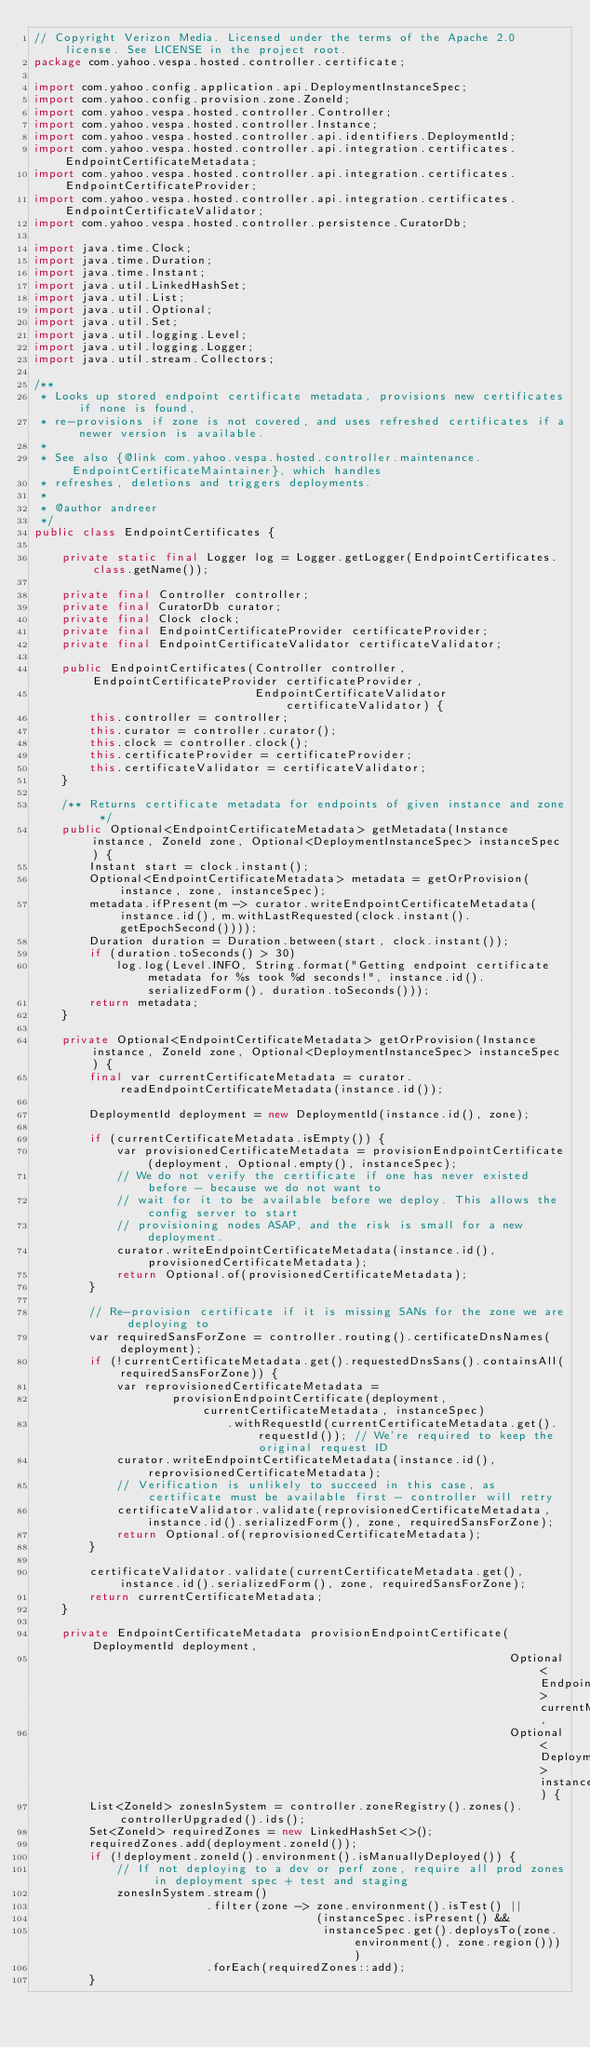Convert code to text. <code><loc_0><loc_0><loc_500><loc_500><_Java_>// Copyright Verizon Media. Licensed under the terms of the Apache 2.0 license. See LICENSE in the project root.
package com.yahoo.vespa.hosted.controller.certificate;

import com.yahoo.config.application.api.DeploymentInstanceSpec;
import com.yahoo.config.provision.zone.ZoneId;
import com.yahoo.vespa.hosted.controller.Controller;
import com.yahoo.vespa.hosted.controller.Instance;
import com.yahoo.vespa.hosted.controller.api.identifiers.DeploymentId;
import com.yahoo.vespa.hosted.controller.api.integration.certificates.EndpointCertificateMetadata;
import com.yahoo.vespa.hosted.controller.api.integration.certificates.EndpointCertificateProvider;
import com.yahoo.vespa.hosted.controller.api.integration.certificates.EndpointCertificateValidator;
import com.yahoo.vespa.hosted.controller.persistence.CuratorDb;

import java.time.Clock;
import java.time.Duration;
import java.time.Instant;
import java.util.LinkedHashSet;
import java.util.List;
import java.util.Optional;
import java.util.Set;
import java.util.logging.Level;
import java.util.logging.Logger;
import java.util.stream.Collectors;

/**
 * Looks up stored endpoint certificate metadata, provisions new certificates if none is found,
 * re-provisions if zone is not covered, and uses refreshed certificates if a newer version is available.
 *
 * See also {@link com.yahoo.vespa.hosted.controller.maintenance.EndpointCertificateMaintainer}, which handles
 * refreshes, deletions and triggers deployments.
 *
 * @author andreer
 */
public class EndpointCertificates {

    private static final Logger log = Logger.getLogger(EndpointCertificates.class.getName());

    private final Controller controller;
    private final CuratorDb curator;
    private final Clock clock;
    private final EndpointCertificateProvider certificateProvider;
    private final EndpointCertificateValidator certificateValidator;

    public EndpointCertificates(Controller controller, EndpointCertificateProvider certificateProvider,
                                EndpointCertificateValidator certificateValidator) {
        this.controller = controller;
        this.curator = controller.curator();
        this.clock = controller.clock();
        this.certificateProvider = certificateProvider;
        this.certificateValidator = certificateValidator;
    }

    /** Returns certificate metadata for endpoints of given instance and zone */
    public Optional<EndpointCertificateMetadata> getMetadata(Instance instance, ZoneId zone, Optional<DeploymentInstanceSpec> instanceSpec) {
        Instant start = clock.instant();
        Optional<EndpointCertificateMetadata> metadata = getOrProvision(instance, zone, instanceSpec);
        metadata.ifPresent(m -> curator.writeEndpointCertificateMetadata(instance.id(), m.withLastRequested(clock.instant().getEpochSecond())));
        Duration duration = Duration.between(start, clock.instant());
        if (duration.toSeconds() > 30)
            log.log(Level.INFO, String.format("Getting endpoint certificate metadata for %s took %d seconds!", instance.id().serializedForm(), duration.toSeconds()));
        return metadata;
    }

    private Optional<EndpointCertificateMetadata> getOrProvision(Instance instance, ZoneId zone, Optional<DeploymentInstanceSpec> instanceSpec) {
        final var currentCertificateMetadata = curator.readEndpointCertificateMetadata(instance.id());

        DeploymentId deployment = new DeploymentId(instance.id(), zone);

        if (currentCertificateMetadata.isEmpty()) {
            var provisionedCertificateMetadata = provisionEndpointCertificate(deployment, Optional.empty(), instanceSpec);
            // We do not verify the certificate if one has never existed before - because we do not want to
            // wait for it to be available before we deploy. This allows the config server to start
            // provisioning nodes ASAP, and the risk is small for a new deployment.
            curator.writeEndpointCertificateMetadata(instance.id(), provisionedCertificateMetadata);
            return Optional.of(provisionedCertificateMetadata);
        }

        // Re-provision certificate if it is missing SANs for the zone we are deploying to
        var requiredSansForZone = controller.routing().certificateDnsNames(deployment);
        if (!currentCertificateMetadata.get().requestedDnsSans().containsAll(requiredSansForZone)) {
            var reprovisionedCertificateMetadata =
                    provisionEndpointCertificate(deployment, currentCertificateMetadata, instanceSpec)
                            .withRequestId(currentCertificateMetadata.get().requestId()); // We're required to keep the original request ID
            curator.writeEndpointCertificateMetadata(instance.id(), reprovisionedCertificateMetadata);
            // Verification is unlikely to succeed in this case, as certificate must be available first - controller will retry
            certificateValidator.validate(reprovisionedCertificateMetadata, instance.id().serializedForm(), zone, requiredSansForZone);
            return Optional.of(reprovisionedCertificateMetadata);
        }

        certificateValidator.validate(currentCertificateMetadata.get(), instance.id().serializedForm(), zone, requiredSansForZone);
        return currentCertificateMetadata;
    }

    private EndpointCertificateMetadata provisionEndpointCertificate(DeploymentId deployment,
                                                                     Optional<EndpointCertificateMetadata> currentMetadata,
                                                                     Optional<DeploymentInstanceSpec> instanceSpec) {
        List<ZoneId> zonesInSystem = controller.zoneRegistry().zones().controllerUpgraded().ids();
        Set<ZoneId> requiredZones = new LinkedHashSet<>();
        requiredZones.add(deployment.zoneId());
        if (!deployment.zoneId().environment().isManuallyDeployed()) {
            // If not deploying to a dev or perf zone, require all prod zones in deployment spec + test and staging
            zonesInSystem.stream()
                         .filter(zone -> zone.environment().isTest() ||
                                         (instanceSpec.isPresent() &&
                                          instanceSpec.get().deploysTo(zone.environment(), zone.region())))
                         .forEach(requiredZones::add);
        }</code> 